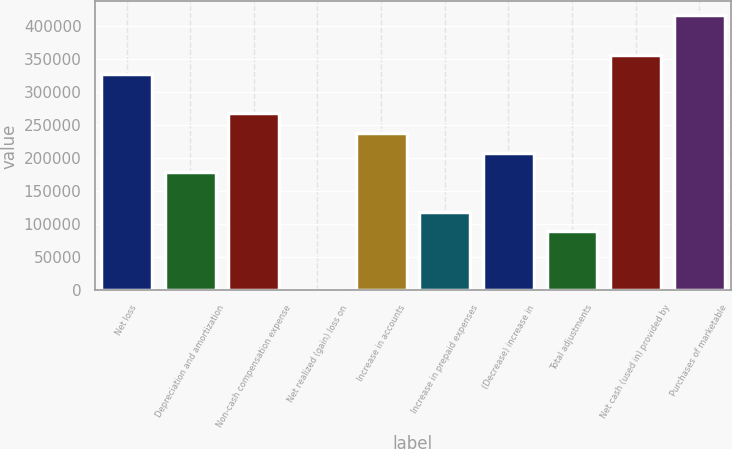<chart> <loc_0><loc_0><loc_500><loc_500><bar_chart><fcel>Net loss<fcel>Depreciation and amortization<fcel>Non-cash compensation expense<fcel>Net realized (gain) loss on<fcel>Increase in accounts<fcel>Increase in prepaid expenses<fcel>(Decrease) increase in<fcel>Total adjustments<fcel>Net cash (used in) provided by<fcel>Purchases of marketable<nl><fcel>327146<fcel>178469<fcel>267676<fcel>56<fcel>237940<fcel>118998<fcel>208204<fcel>89262.5<fcel>356882<fcel>416353<nl></chart> 